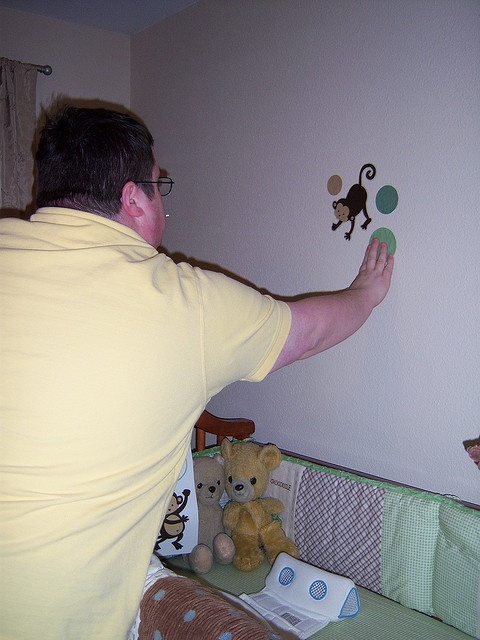Describe the objects in this image and their specific colors. I can see people in black, beige, and darkgray tones, couch in black, gray, and darkgray tones, bed in black, gray, and darkgray tones, teddy bear in black and gray tones, and teddy bear in black and gray tones in this image. 